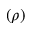<formula> <loc_0><loc_0><loc_500><loc_500>( \rho )</formula> 